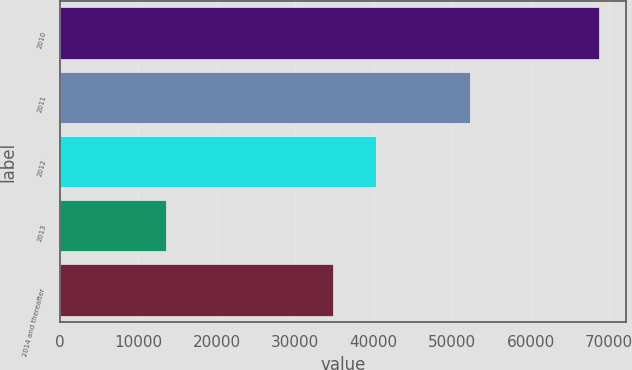Convert chart to OTSL. <chart><loc_0><loc_0><loc_500><loc_500><bar_chart><fcel>2010<fcel>2011<fcel>2012<fcel>2013<fcel>2014 and thereafter<nl><fcel>68763<fcel>52251<fcel>40291.9<fcel>13554<fcel>34771<nl></chart> 